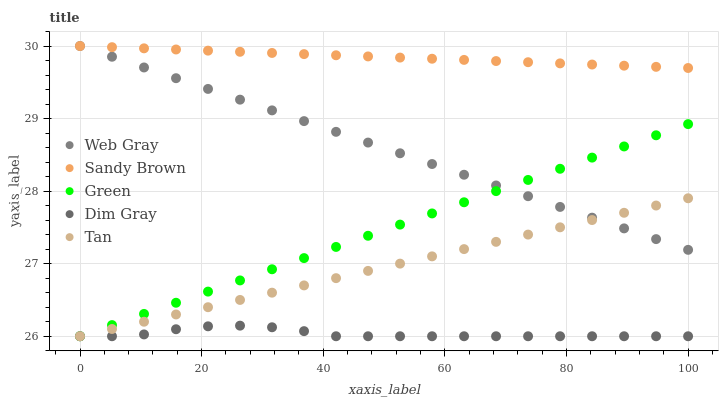Does Dim Gray have the minimum area under the curve?
Answer yes or no. Yes. Does Sandy Brown have the maximum area under the curve?
Answer yes or no. Yes. Does Web Gray have the minimum area under the curve?
Answer yes or no. No. Does Web Gray have the maximum area under the curve?
Answer yes or no. No. Is Sandy Brown the smoothest?
Answer yes or no. Yes. Is Dim Gray the roughest?
Answer yes or no. Yes. Is Web Gray the smoothest?
Answer yes or no. No. Is Web Gray the roughest?
Answer yes or no. No. Does Green have the lowest value?
Answer yes or no. Yes. Does Web Gray have the lowest value?
Answer yes or no. No. Does Sandy Brown have the highest value?
Answer yes or no. Yes. Does Dim Gray have the highest value?
Answer yes or no. No. Is Tan less than Sandy Brown?
Answer yes or no. Yes. Is Sandy Brown greater than Green?
Answer yes or no. Yes. Does Green intersect Web Gray?
Answer yes or no. Yes. Is Green less than Web Gray?
Answer yes or no. No. Is Green greater than Web Gray?
Answer yes or no. No. Does Tan intersect Sandy Brown?
Answer yes or no. No. 